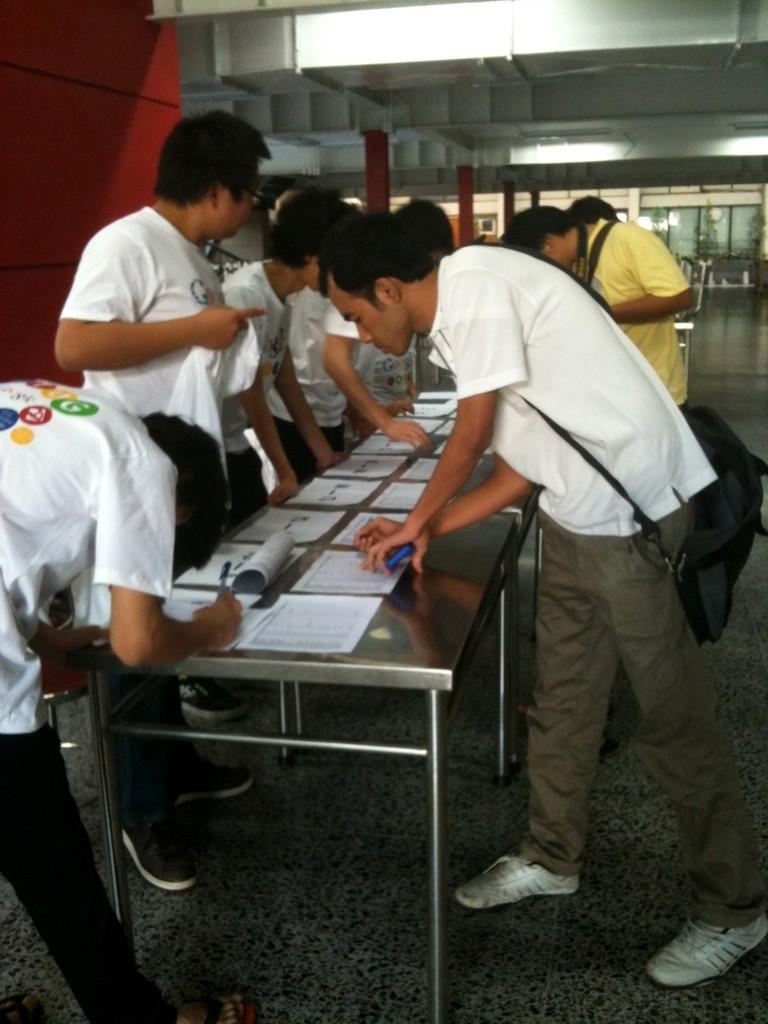How many people are in the image? There are persons standing in the image. Can you describe the man's attire? The man is wearing a bag. What is present on the table in the image? There is a table in the image with papers on it. What type of eggnog is being served at the table in the image? There is no eggnog present in the image; it only features persons standing, a man wearing a bag, and papers on a table. 